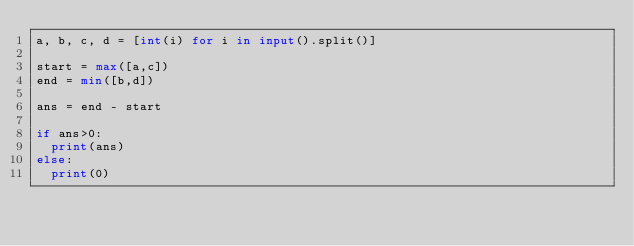<code> <loc_0><loc_0><loc_500><loc_500><_Python_>a, b, c, d = [int(i) for i in input().split()]

start = max([a,c])
end = min([b,d])

ans = end - start

if ans>0:
  print(ans)
else:
  print(0)</code> 